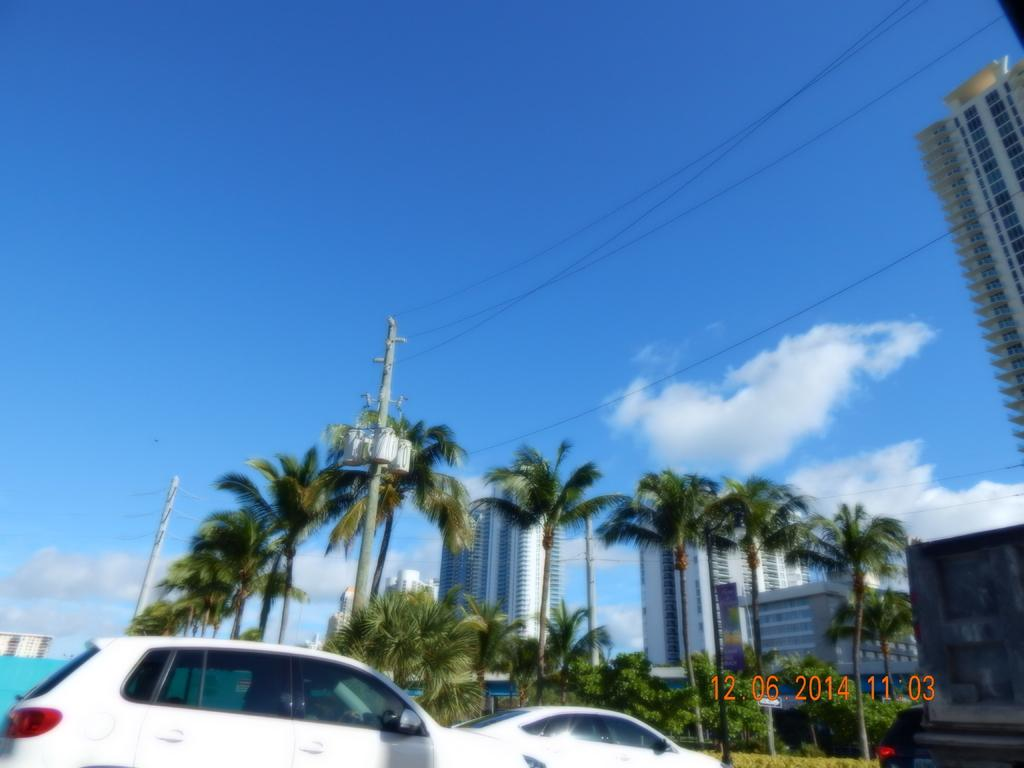What type of structures can be seen in the image? There are buildings in the image. What other natural elements are present in the image? There are trees in the image. Are there any vehicles visible in the image? Yes, there are cars in the image. Where can text be found in the image? The text is located at the bottom right corner of the image. How would you describe the sky in the image? The sky is blue and cloudy. Can you see any pickles hanging from the trees in the image? There are no pickles present in the image; it features trees and buildings. How many times does the person in the image fall down? There is no person present in the image, so it is not possible to determine if anyone falls down. 